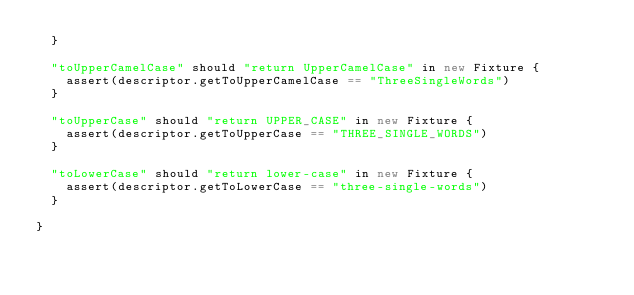Convert code to text. <code><loc_0><loc_0><loc_500><loc_500><_Scala_>  }

  "toUpperCamelCase" should "return UpperCamelCase" in new Fixture {
    assert(descriptor.getToUpperCamelCase == "ThreeSingleWords")
  }

  "toUpperCase" should "return UPPER_CASE" in new Fixture {
    assert(descriptor.getToUpperCase == "THREE_SINGLE_WORDS")
  }

  "toLowerCase" should "return lower-case" in new Fixture {
    assert(descriptor.getToLowerCase == "three-single-words")
  }

}
</code> 